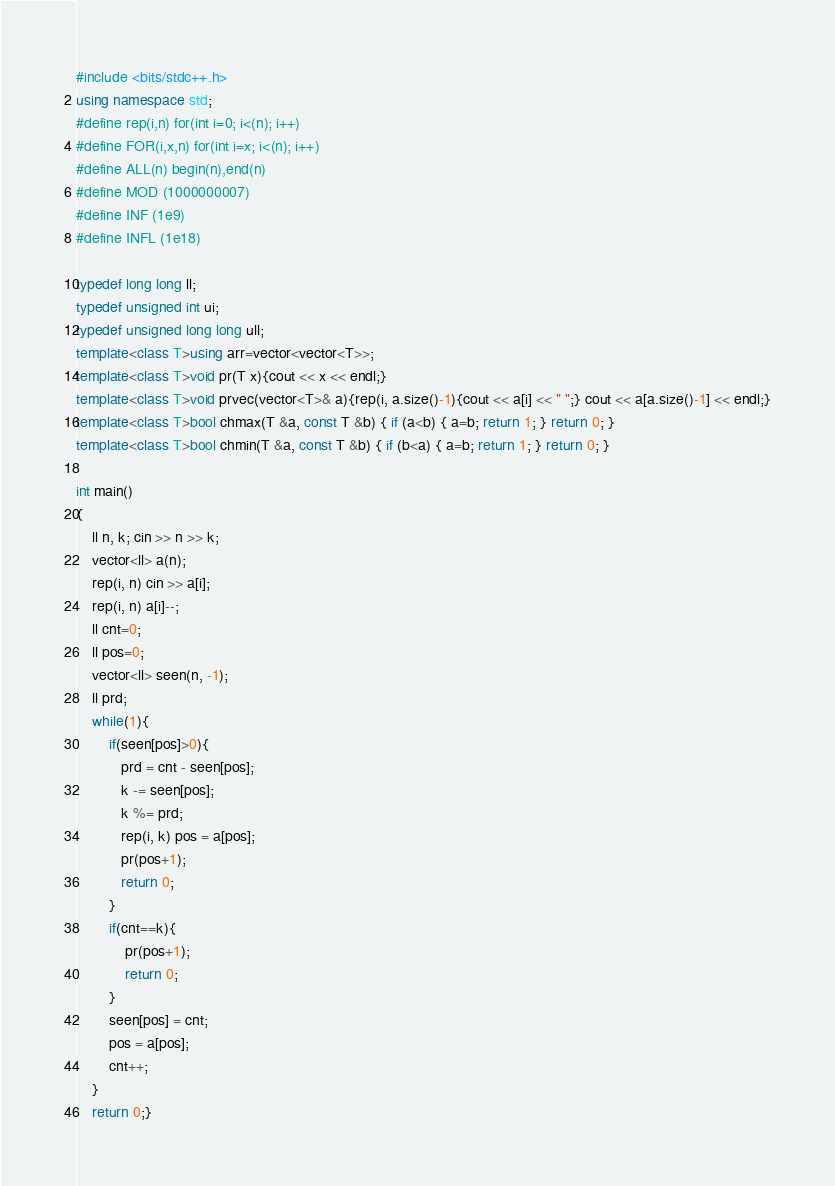<code> <loc_0><loc_0><loc_500><loc_500><_C++_>#include <bits/stdc++.h>
using namespace std;
#define rep(i,n) for(int i=0; i<(n); i++)
#define FOR(i,x,n) for(int i=x; i<(n); i++)
#define ALL(n) begin(n),end(n)
#define MOD (1000000007)
#define INF (1e9)
#define INFL (1e18)
 
typedef long long ll;
typedef unsigned int ui;
typedef unsigned long long ull;
template<class T>using arr=vector<vector<T>>;
template<class T>void pr(T x){cout << x << endl;}
template<class T>void prvec(vector<T>& a){rep(i, a.size()-1){cout << a[i] << " ";} cout << a[a.size()-1] << endl;}
template<class T>bool chmax(T &a, const T &b) { if (a<b) { a=b; return 1; } return 0; }
template<class T>bool chmin(T &a, const T &b) { if (b<a) { a=b; return 1; } return 0; }
 
int main()
{
    ll n, k; cin >> n >> k;
    vector<ll> a(n);
    rep(i, n) cin >> a[i];
    rep(i, n) a[i]--;
    ll cnt=0;
    ll pos=0;
    vector<ll> seen(n, -1);
    ll prd;
    while(1){
        if(seen[pos]>0){
           prd = cnt - seen[pos];
           k -= seen[pos];
           k %= prd;
           rep(i, k) pos = a[pos];
           pr(pos+1);
           return 0;
        }
        if(cnt==k){
            pr(pos+1);
            return 0;
        }
        seen[pos] = cnt;
        pos = a[pos];
        cnt++;
    }
    return 0;}</code> 